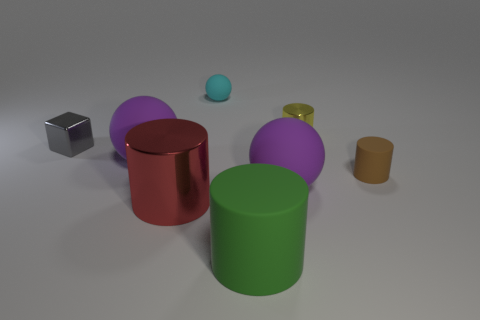Does the purple ball to the left of the cyan sphere have the same size as the cyan rubber ball?
Your answer should be very brief. No. What number of things are either things right of the block or purple spheres to the left of the large red metal thing?
Your answer should be compact. 7. How many matte things are tiny cyan balls or tiny yellow objects?
Provide a succinct answer. 1. The large green thing is what shape?
Your answer should be very brief. Cylinder. Do the gray block and the yellow thing have the same material?
Make the answer very short. Yes. There is a large red shiny cylinder that is in front of the purple rubber thing on the right side of the large green thing; is there a small block in front of it?
Your answer should be compact. No. What number of other things are there of the same shape as the red object?
Give a very brief answer. 3. The large thing that is left of the cyan rubber object and behind the big metallic cylinder has what shape?
Keep it short and to the point. Sphere. What is the color of the ball that is to the right of the matte thing in front of the large purple ball in front of the brown rubber cylinder?
Ensure brevity in your answer.  Purple. Are there more cyan matte spheres that are in front of the small cyan rubber thing than gray blocks that are to the right of the cube?
Give a very brief answer. No. 